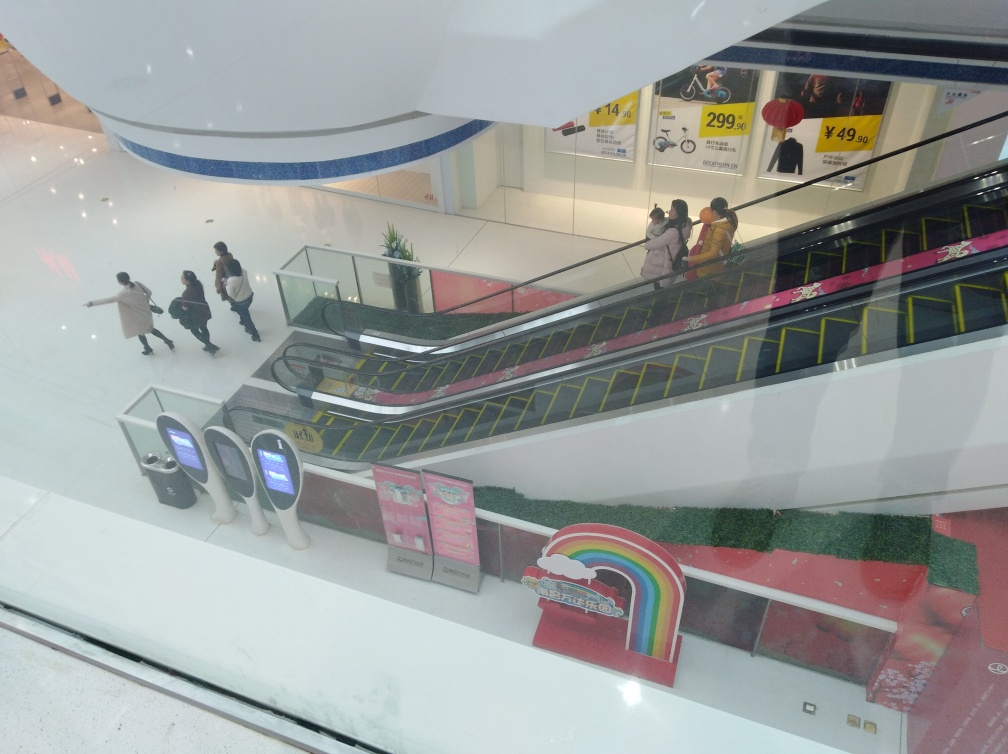What is the setting of this image? The image depicts an indoor scene, likely within a shopping mall or a similar commercial establishment. We can see escalators, indicative of multi-level floors, and kiosks or informational stands at the ground level, usually found in public spaces designed for shopping and leisure activities. 